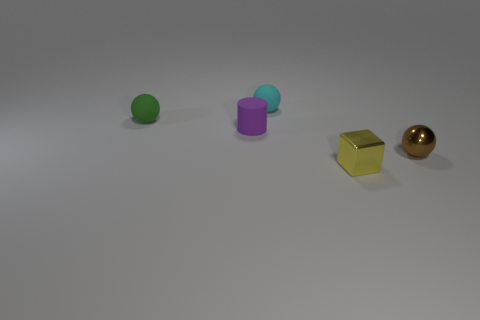The small brown metal thing has what shape? The object in reference appears to be a gold-colored, metallic sphere. 